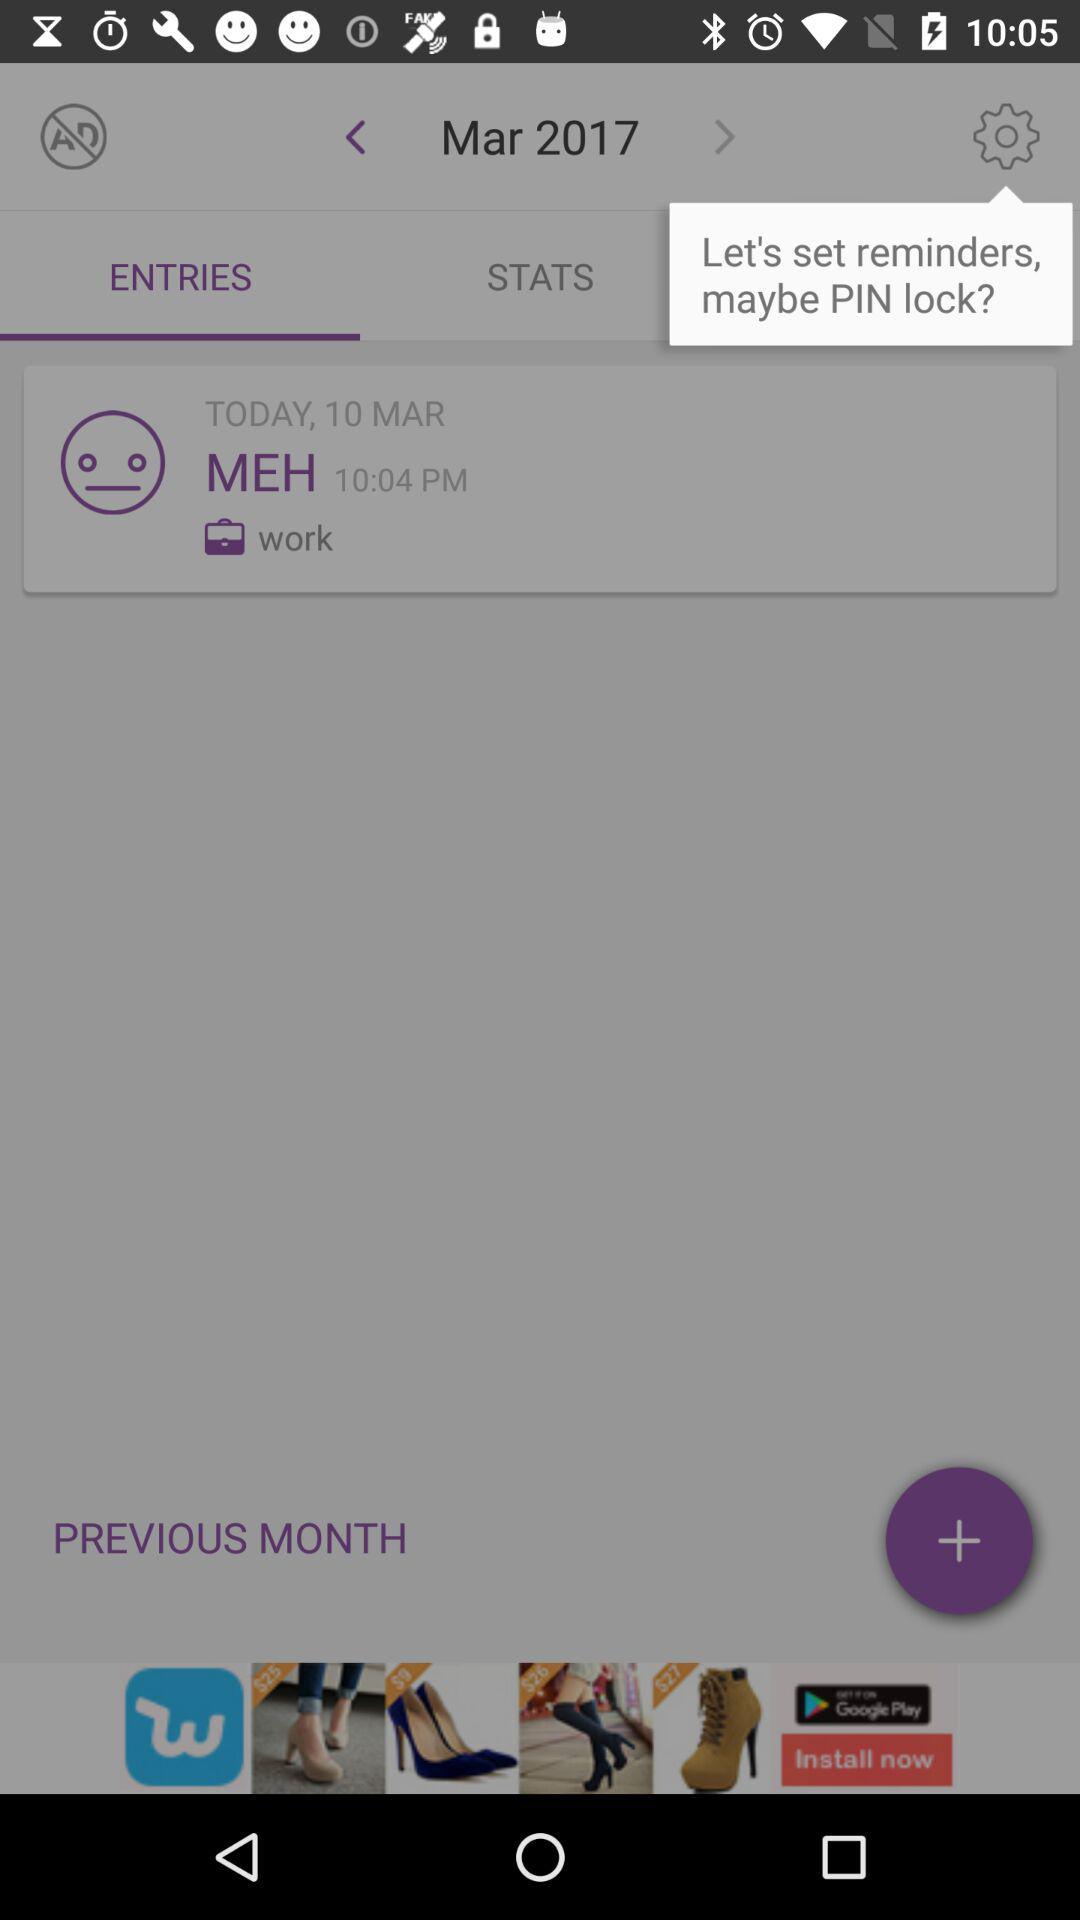At what time was the MEH entry done? The MEH entry was done at 10:04 p.m. 